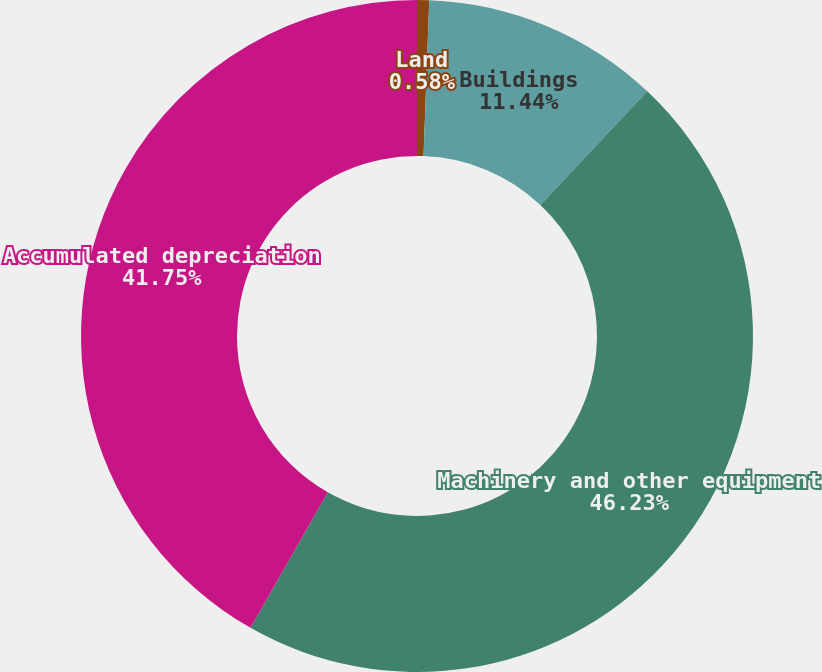Convert chart. <chart><loc_0><loc_0><loc_500><loc_500><pie_chart><fcel>Land<fcel>Buildings<fcel>Machinery and other equipment<fcel>Accumulated depreciation<nl><fcel>0.58%<fcel>11.44%<fcel>46.23%<fcel>41.75%<nl></chart> 